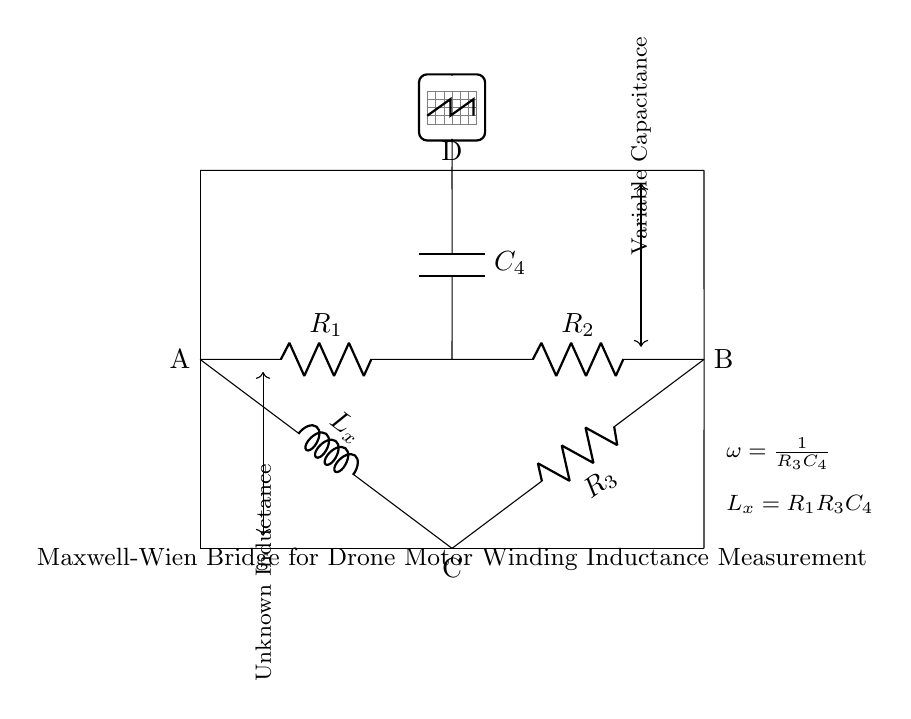What is the unknown component labeled in the circuit? The unknown component is represented as L_x, which indicates that it is an inductor whose inductance value is to be measured.
Answer: Inductor What are the resistances in this circuit? The resistances are represented by R_1, R_2, and R_3, as labeled in the circuit diagram.
Answer: R_1, R_2, R_3 What is the role of the capacitor in this bridge? The capacitor, labeled as C_4, is used for balancing the bridge circuit to help measure the unknown inductance accurately through resonance.
Answer: Balancing How is the unknown inductance calculated? The unknown inductance L_x is calculated using the formula L_x = R_1R_3C_4, which relates the resistors and the capacitor in the bridge configuration.
Answer: R_1R_3C_4 What is the relationship between frequency and capacitance in this bridge? The circuit indicates that the frequency ω is inversely proportional to the product of resistance R_3 and capacitance C_4, expressed as ω = 1/(R_3C_4).
Answer: Inverse How many nodes are present in this circuit diagram? The nodes in the circuit are labeled as A, B, C, and D, indicating there are four distinct nodes for connections in this configuration.
Answer: Four 